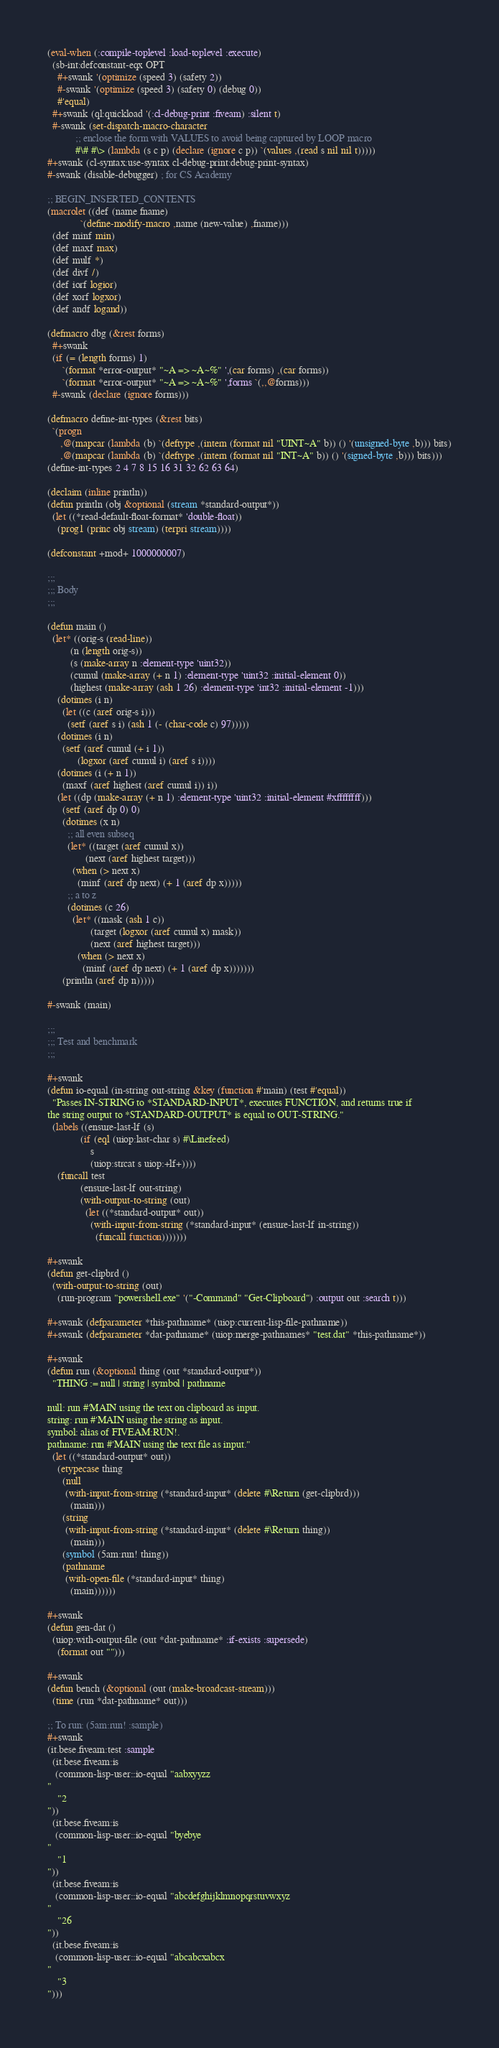<code> <loc_0><loc_0><loc_500><loc_500><_Lisp_>(eval-when (:compile-toplevel :load-toplevel :execute)
  (sb-int:defconstant-eqx OPT
    #+swank '(optimize (speed 3) (safety 2))
    #-swank '(optimize (speed 3) (safety 0) (debug 0))
    #'equal)
  #+swank (ql:quickload '(:cl-debug-print :fiveam) :silent t)
  #-swank (set-dispatch-macro-character
           ;; enclose the form with VALUES to avoid being captured by LOOP macro
           #\# #\> (lambda (s c p) (declare (ignore c p)) `(values ,(read s nil nil t)))))
#+swank (cl-syntax:use-syntax cl-debug-print:debug-print-syntax)
#-swank (disable-debugger) ; for CS Academy

;; BEGIN_INSERTED_CONTENTS
(macrolet ((def (name fname)
             `(define-modify-macro ,name (new-value) ,fname)))
  (def minf min)
  (def maxf max)
  (def mulf *)
  (def divf /)
  (def iorf logior)
  (def xorf logxor)
  (def andf logand))

(defmacro dbg (&rest forms)
  #+swank
  (if (= (length forms) 1)
      `(format *error-output* "~A => ~A~%" ',(car forms) ,(car forms))
      `(format *error-output* "~A => ~A~%" ',forms `(,,@forms)))
  #-swank (declare (ignore forms)))

(defmacro define-int-types (&rest bits)
  `(progn
     ,@(mapcar (lambda (b) `(deftype ,(intern (format nil "UINT~A" b)) () '(unsigned-byte ,b))) bits)
     ,@(mapcar (lambda (b) `(deftype ,(intern (format nil "INT~A" b)) () '(signed-byte ,b))) bits)))
(define-int-types 2 4 7 8 15 16 31 32 62 63 64)

(declaim (inline println))
(defun println (obj &optional (stream *standard-output*))
  (let ((*read-default-float-format* 'double-float))
    (prog1 (princ obj stream) (terpri stream))))

(defconstant +mod+ 1000000007)

;;;
;;; Body
;;;

(defun main ()
  (let* ((orig-s (read-line))
         (n (length orig-s))
         (s (make-array n :element-type 'uint32))
         (cumul (make-array (+ n 1) :element-type 'uint32 :initial-element 0))
         (highest (make-array (ash 1 26) :element-type 'int32 :initial-element -1)))
    (dotimes (i n)
      (let ((c (aref orig-s i)))
        (setf (aref s i) (ash 1 (- (char-code c) 97)))))
    (dotimes (i n)
      (setf (aref cumul (+ i 1))
            (logxor (aref cumul i) (aref s i))))
    (dotimes (i (+ n 1))
      (maxf (aref highest (aref cumul i)) i))
    (let ((dp (make-array (+ n 1) :element-type 'uint32 :initial-element #xffffffff)))
      (setf (aref dp 0) 0)
      (dotimes (x n)
        ;; all even subseq
        (let* ((target (aref cumul x))
               (next (aref highest target)))
          (when (> next x)
            (minf (aref dp next) (+ 1 (aref dp x)))))
        ;; a to z
        (dotimes (c 26)
          (let* ((mask (ash 1 c))
                 (target (logxor (aref cumul x) mask))
                 (next (aref highest target)))
            (when (> next x)
              (minf (aref dp next) (+ 1 (aref dp x)))))))
      (println (aref dp n)))))

#-swank (main)

;;;
;;; Test and benchmark
;;;

#+swank
(defun io-equal (in-string out-string &key (function #'main) (test #'equal))
  "Passes IN-STRING to *STANDARD-INPUT*, executes FUNCTION, and returns true if
the string output to *STANDARD-OUTPUT* is equal to OUT-STRING."
  (labels ((ensure-last-lf (s)
             (if (eql (uiop:last-char s) #\Linefeed)
                 s
                 (uiop:strcat s uiop:+lf+))))
    (funcall test
             (ensure-last-lf out-string)
             (with-output-to-string (out)
               (let ((*standard-output* out))
                 (with-input-from-string (*standard-input* (ensure-last-lf in-string))
                   (funcall function)))))))

#+swank
(defun get-clipbrd ()
  (with-output-to-string (out)
    (run-program "powershell.exe" '("-Command" "Get-Clipboard") :output out :search t)))

#+swank (defparameter *this-pathname* (uiop:current-lisp-file-pathname))
#+swank (defparameter *dat-pathname* (uiop:merge-pathnames* "test.dat" *this-pathname*))

#+swank
(defun run (&optional thing (out *standard-output*))
  "THING := null | string | symbol | pathname

null: run #'MAIN using the text on clipboard as input.
string: run #'MAIN using the string as input.
symbol: alias of FIVEAM:RUN!.
pathname: run #'MAIN using the text file as input."
  (let ((*standard-output* out))
    (etypecase thing
      (null
       (with-input-from-string (*standard-input* (delete #\Return (get-clipbrd)))
         (main)))
      (string
       (with-input-from-string (*standard-input* (delete #\Return thing))
         (main)))
      (symbol (5am:run! thing))
      (pathname
       (with-open-file (*standard-input* thing)
         (main))))))

#+swank
(defun gen-dat ()
  (uiop:with-output-file (out *dat-pathname* :if-exists :supersede)
    (format out "")))

#+swank
(defun bench (&optional (out (make-broadcast-stream)))
  (time (run *dat-pathname* out)))

;; To run: (5am:run! :sample)
#+swank
(it.bese.fiveam:test :sample
  (it.bese.fiveam:is
   (common-lisp-user::io-equal "aabxyyzz
"
    "2
"))
  (it.bese.fiveam:is
   (common-lisp-user::io-equal "byebye
"
    "1
"))
  (it.bese.fiveam:is
   (common-lisp-user::io-equal "abcdefghijklmnopqrstuvwxyz
"
    "26
"))
  (it.bese.fiveam:is
   (common-lisp-user::io-equal "abcabcxabcx
"
    "3
")))
</code> 